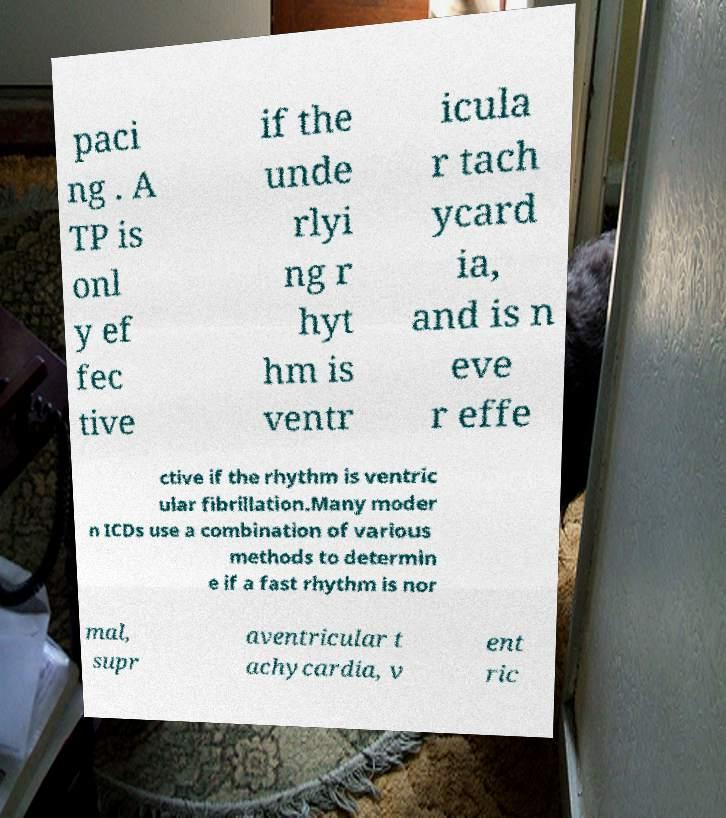There's text embedded in this image that I need extracted. Can you transcribe it verbatim? paci ng . A TP is onl y ef fec tive if the unde rlyi ng r hyt hm is ventr icula r tach ycard ia, and is n eve r effe ctive if the rhythm is ventric ular fibrillation.Many moder n ICDs use a combination of various methods to determin e if a fast rhythm is nor mal, supr aventricular t achycardia, v ent ric 